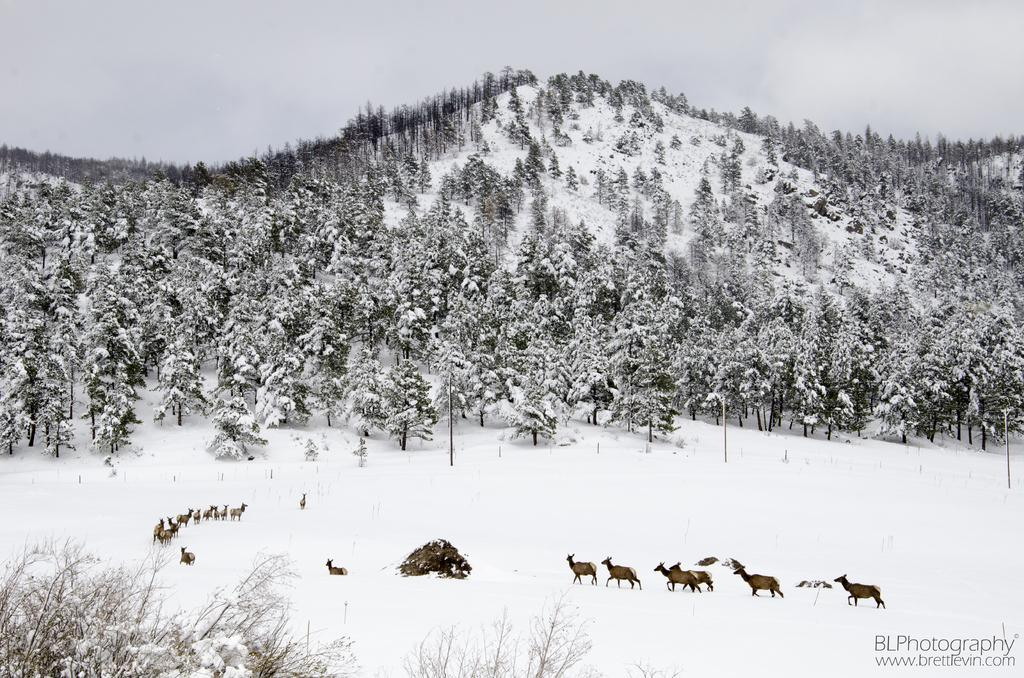What is on the snow in the image? There are animals on the snow in the image. What else can be seen in the image besides the animals on the snow? There are poles visible in the image. What is located on the ice hills in the image? There is a group of trees on the ice hills. What is visible in the background of the image? The sky is visible in the image. How would you describe the weather based on the appearance of the sky? The sky appears cloudy in the image. What type of lettuce can be seen growing on the ice hills in the image? There is no lettuce present in the image; it features animals on the snow, poles, a group of trees on ice hills, and a cloudy sky. How are the cattle arranged in the image? There are no cattle present in the image. 